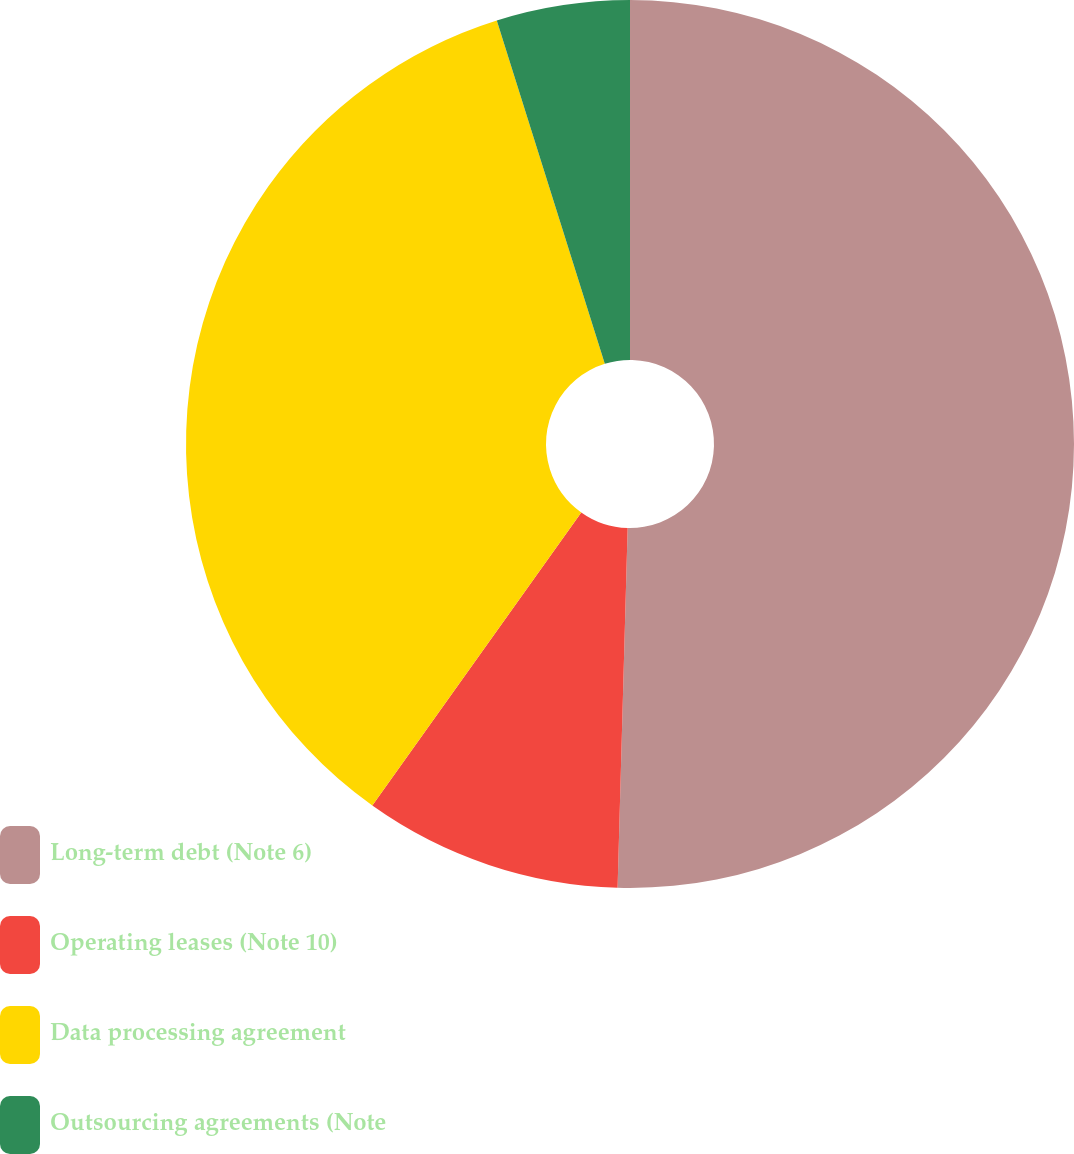Convert chart. <chart><loc_0><loc_0><loc_500><loc_500><pie_chart><fcel>Long-term debt (Note 6)<fcel>Operating leases (Note 10)<fcel>Data processing agreement<fcel>Outsourcing agreements (Note<nl><fcel>50.45%<fcel>9.41%<fcel>35.3%<fcel>4.85%<nl></chart> 